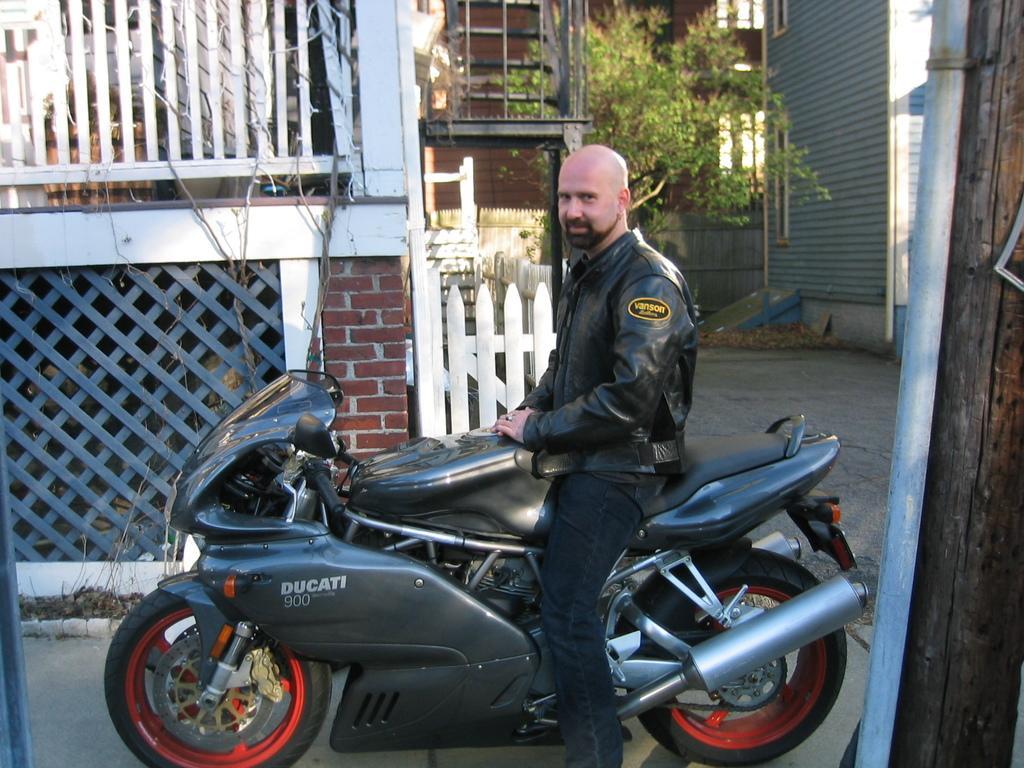Could you give a brief overview of what you see in this image? In this picture there is a man sitting on a motorcycle in the background as a building and plant 